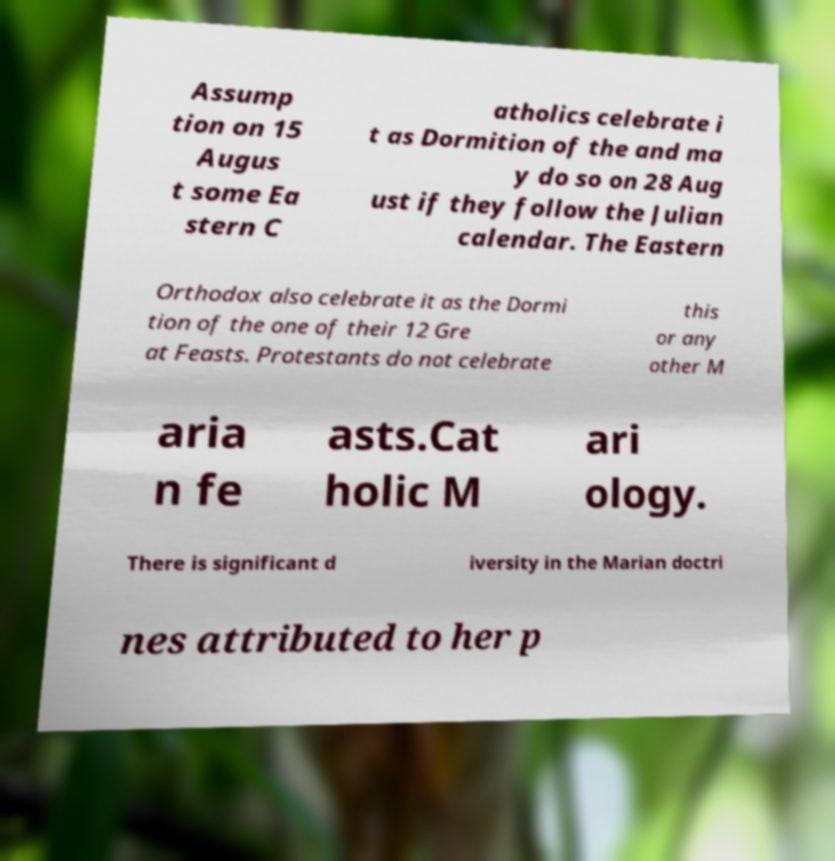Please read and relay the text visible in this image. What does it say? Assump tion on 15 Augus t some Ea stern C atholics celebrate i t as Dormition of the and ma y do so on 28 Aug ust if they follow the Julian calendar. The Eastern Orthodox also celebrate it as the Dormi tion of the one of their 12 Gre at Feasts. Protestants do not celebrate this or any other M aria n fe asts.Cat holic M ari ology. There is significant d iversity in the Marian doctri nes attributed to her p 